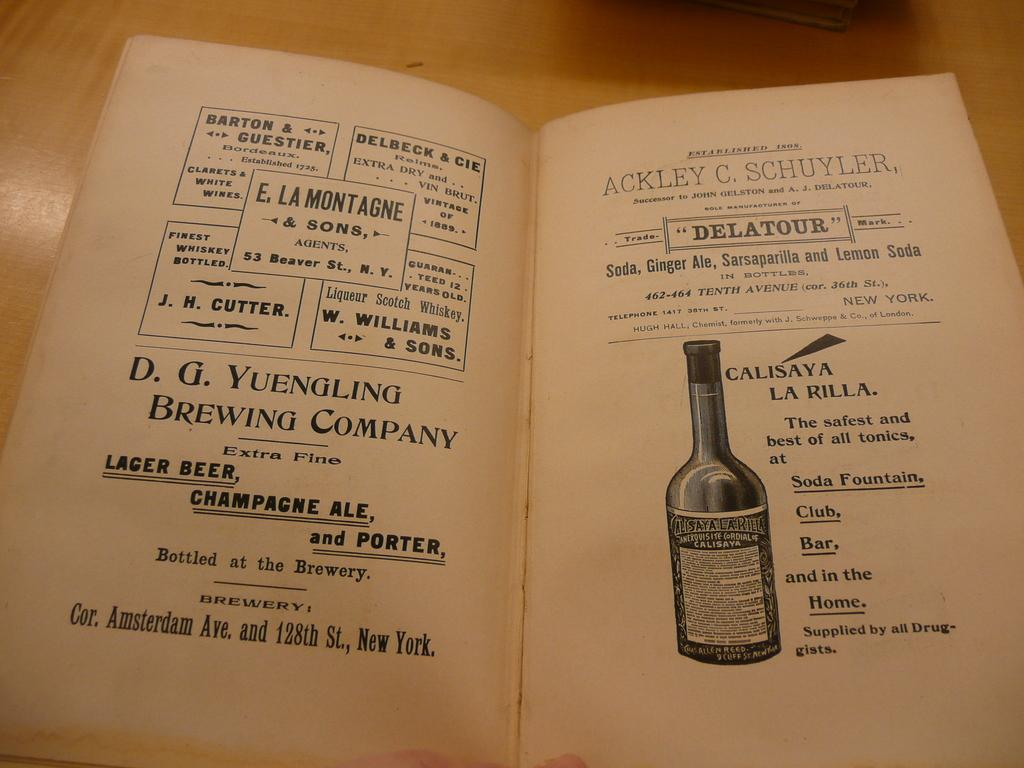<image>
Relay a brief, clear account of the picture shown. Pages from an old book about a lager beer  shows the bottle and details about it. 